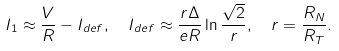<formula> <loc_0><loc_0><loc_500><loc_500>I _ { 1 } & \approx \frac { V } { R } - I _ { d e f } , \quad I _ { d e f } \approx \frac { r \Delta } { e R } \ln \frac { \sqrt { 2 } } { r } , \quad r = \frac { R _ { N } } { R _ { T } } .</formula> 